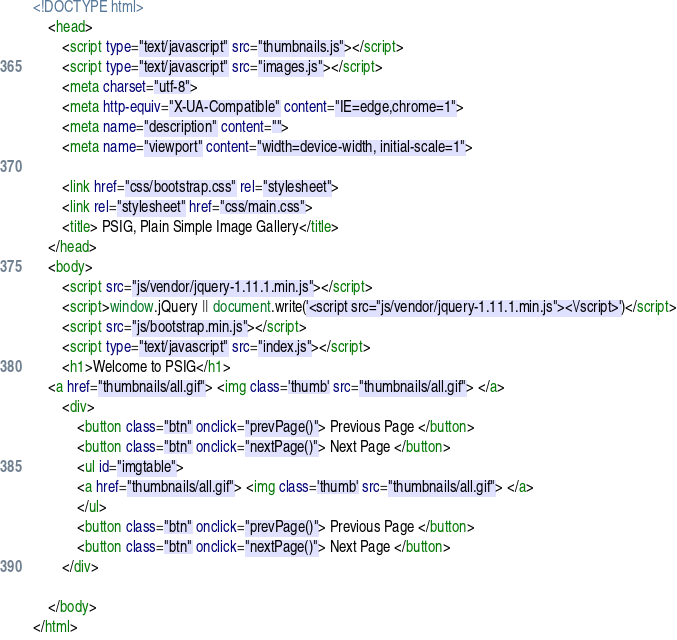<code> <loc_0><loc_0><loc_500><loc_500><_HTML_><!DOCTYPE html>
    <head>
        <script type="text/javascript" src="thumbnails.js"></script>
        <script type="text/javascript" src="images.js"></script>
        <meta charset="utf-8">
        <meta http-equiv="X-UA-Compatible" content="IE=edge,chrome=1">
        <meta name="description" content="">
        <meta name="viewport" content="width=device-width, initial-scale=1">

        <link href="css/bootstrap.css" rel="stylesheet">
        <link rel="stylesheet" href="css/main.css">
        <title> PSIG, Plain Simple Image Gallery</title>
    </head>
    <body>
        <script src="js/vendor/jquery-1.11.1.min.js"></script>
        <script>window.jQuery || document.write('<script src="js/vendor/jquery-1.11.1.min.js"><\/script>')</script>
        <script src="js/bootstrap.min.js"></script>
        <script type="text/javascript" src="index.js"></script>
        <h1>Welcome to PSIG</h1>
	<a href="thumbnails/all.gif"> <img class='thumb' src="thumbnails/all.gif"> </a>
        <div>
            <button class="btn" onclick="prevPage()"> Previous Page </button>
            <button class="btn" onclick="nextPage()"> Next Page </button>
            <ul id="imgtable">
           	<a href="thumbnails/all.gif"> <img class='thumb' src="thumbnails/all.gif"> </a> 
            </ul>
            <button class="btn" onclick="prevPage()"> Previous Page </button>
            <button class="btn" onclick="nextPage()"> Next Page </button>
        </div>
        
    </body>
</html>
</code> 